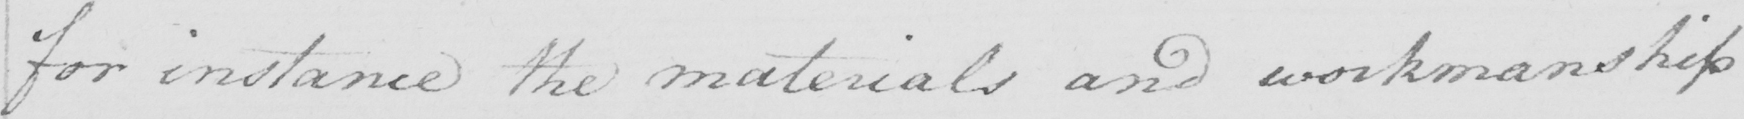Please provide the text content of this handwritten line. for instance the materials and workmanship 